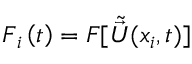Convert formula to latex. <formula><loc_0><loc_0><loc_500><loc_500>F _ { i } \left ( t \right ) = F [ \tilde { \vec { U } } ( x _ { i } , t ) ]</formula> 